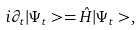<formula> <loc_0><loc_0><loc_500><loc_500>i \partial _ { t } | \Psi _ { t } > = \hat { H } | \Psi _ { t } > ,</formula> 